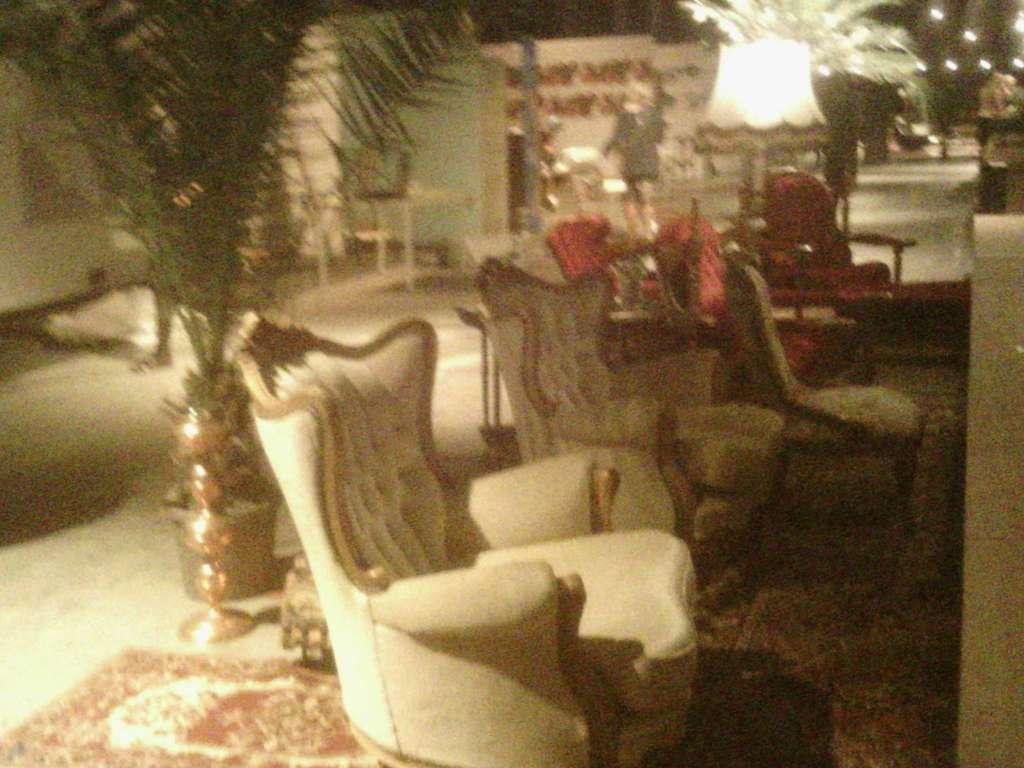In one or two sentences, can you explain what this image depicts? In this picture, we see sofa chairs. Beside that, we see a lamp and a flower pot. At the bottom of the picture, we see a carpet. There is a table and a wall in green color is in the background. On the right side, we see trees and street lights. This picture is clicked in the dark. This picture is blurred. 